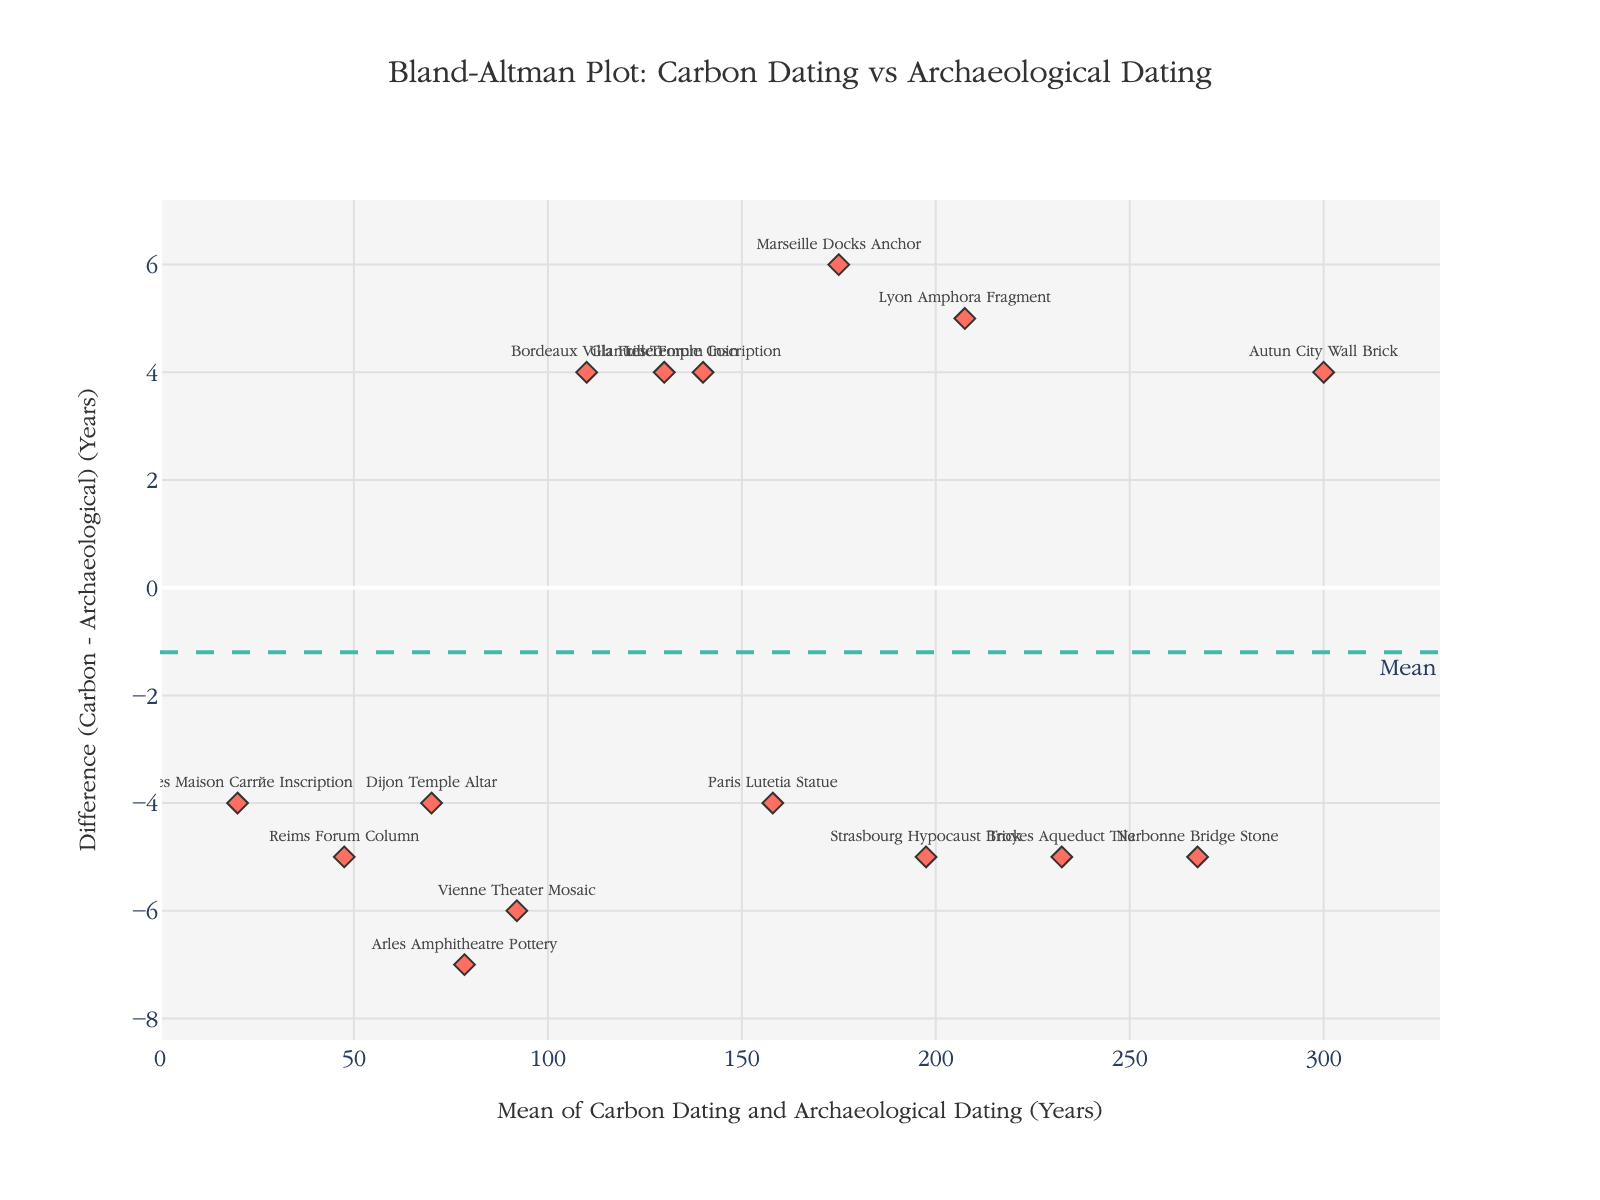What is the title of the plot? The title is located at the top center of the plot. The text indicates what the plot is about.
Answer: Bland-Altman Plot: Carbon Dating vs Archaeological Dating How many data points are plotted? Each data point represents an artifact and is marked with a diamond symbol on the figure. Simply count these data points.
Answer: 15 What does the y-axis represent? The y-axis label provides information on what is plotted on this axis. It represents the difference between the carbon dating and archaeological dating.
Answer: Difference (Carbon - Archaeological) (Years) Which artifact has the largest positive difference between carbon dating and archaeological dating? Look for the data point with the highest value on the y-axis and identify the corresponding artifact.
Answer: Marseille Docks Anchor What are the limits of agreement in the plot? The limits of agreement are represented by the horizontal dotted lines. They are calculated as mean difference plus or minus 1.96 times the standard deviation.
Answer: -6.6 and 6.6 What is the mean difference between carbon dating and archaeological dating? The mean difference is indicated by the horizontal dashed line in the plot, often labeled as "Mean".
Answer: 0.4 Which artifact has the smallest value on the mean axis? The mean axis is the x-axis which represents the average of carbon dating and archaeological dating. Identify the artifact with the smallest x-axis value.
Answer: Nîmes Maison Carrée Inscription Is there any artifact for which carbon dating and archaeological dating results are identical? When carbon and archaeological dating results are identical, the difference (y-axis value) will be 0. Check if any data point lies on the y=0 line.
Answer: No Which artifact shows the largest negative difference between carbon dating and archaeological dating? Locate the data point with the lowest value on the y-axis and identify the corresponding artifact.
Answer: Arles Amphitheatre Pottery What is the range of the mean values of carbon dating and archaeological dating? The range is determined by identifying the smallest and largest values on the x-axis.
Answer: 18 to 302 